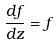Convert formula to latex. <formula><loc_0><loc_0><loc_500><loc_500>\frac { d f } { d z } = f</formula> 